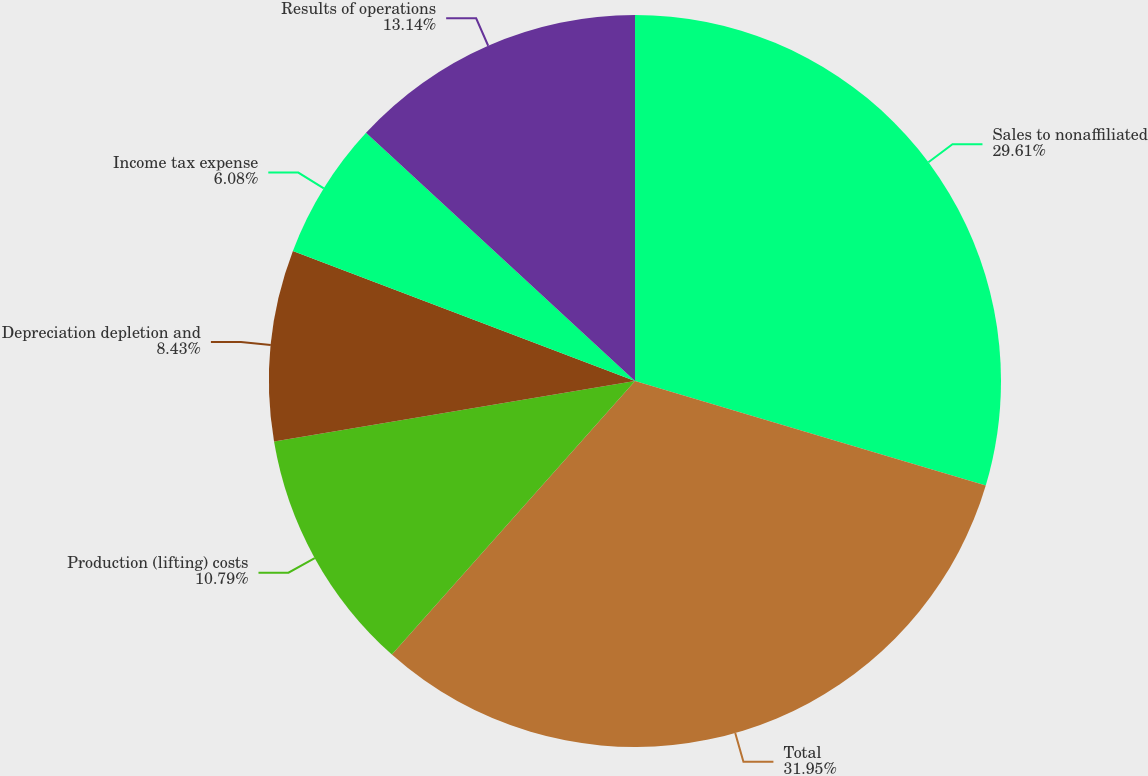Convert chart to OTSL. <chart><loc_0><loc_0><loc_500><loc_500><pie_chart><fcel>Sales to nonaffiliated<fcel>Total<fcel>Production (lifting) costs<fcel>Depreciation depletion and<fcel>Income tax expense<fcel>Results of operations<nl><fcel>29.61%<fcel>31.96%<fcel>10.79%<fcel>8.43%<fcel>6.08%<fcel>13.14%<nl></chart> 